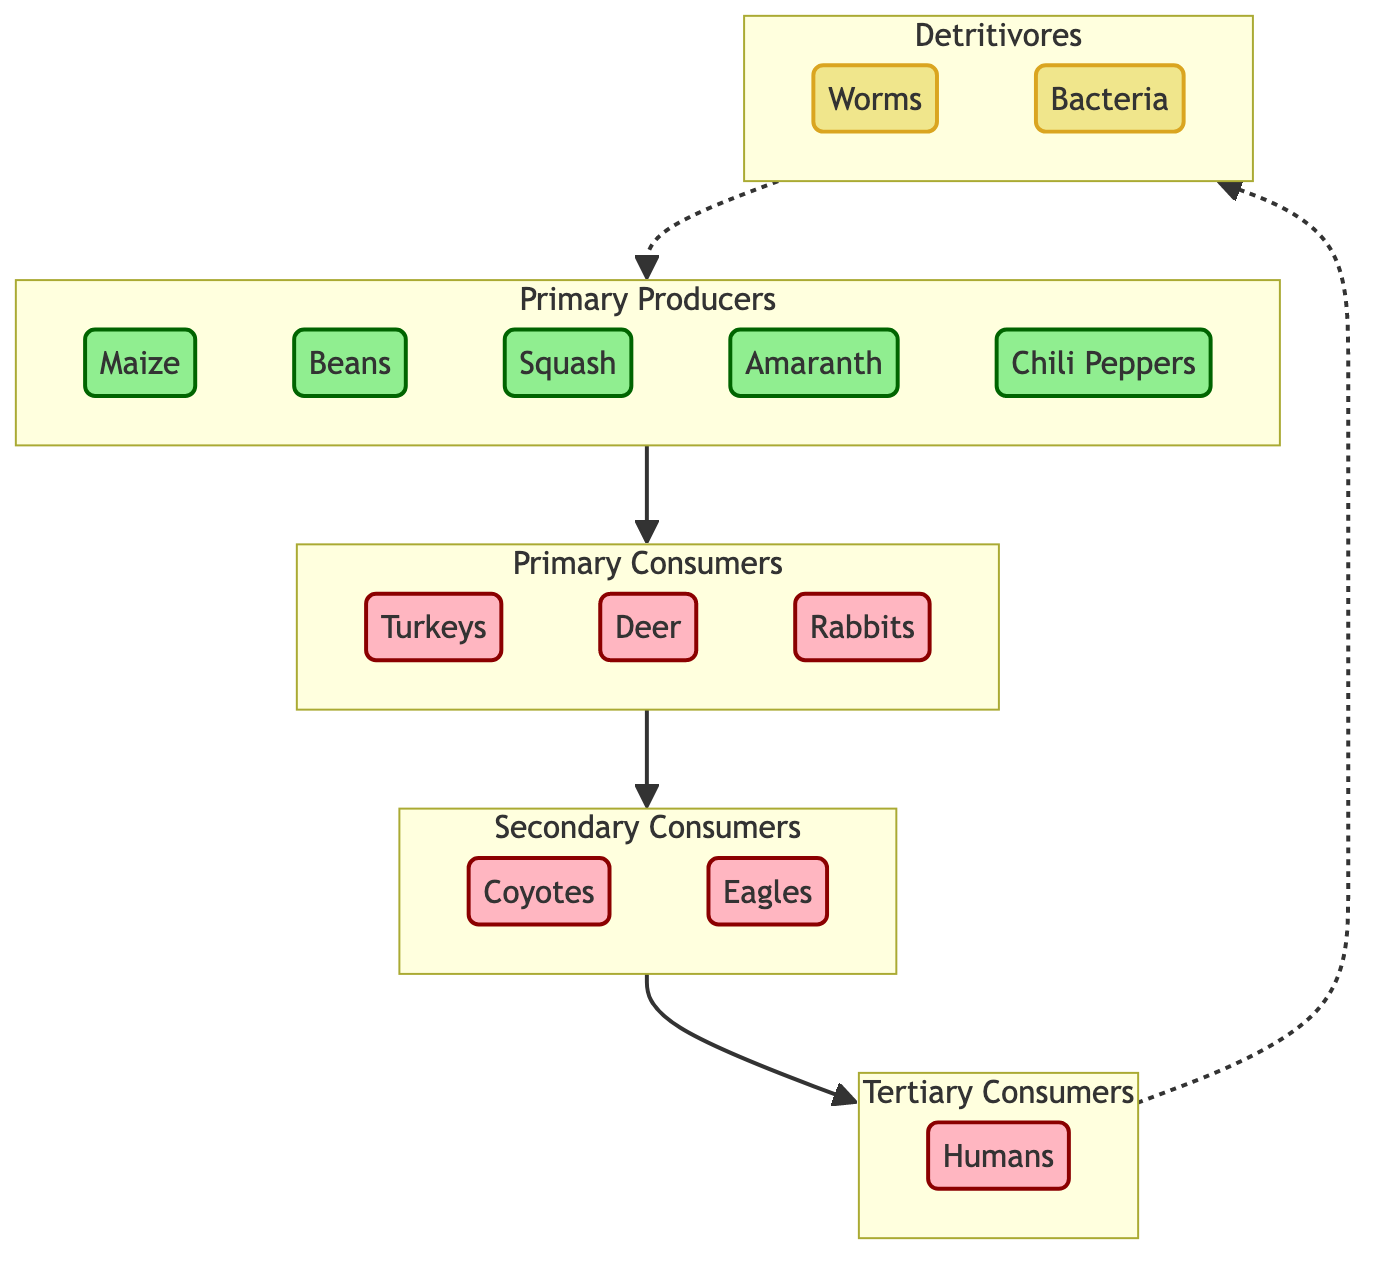What are the primary producers in the Aztec agricultural system? The diagram lists maize, beans, squash, amaranth, and chili peppers as primary producers. These are at the top of the diagram under the "Primary Producers" subgraph.
Answer: Maize, beans, squash, amaranth, chili peppers How many primary consumers are present in the diagram? The diagram includes three primary consumers: turkeys, deer, and rabbits. They are listed in the "Primary Consumers" subgraph.
Answer: 3 Which group is at the top of the food chain? The diagram shows humans as the group at the top of the food chain, located in the "Tertiary Consumers" subgraph.
Answer: Humans What do detritivores return to the system? Detritivores, such as worms and bacteria, return nutrients to the soil, completing the cycle back to primary producers. This relationship is indicated by the dashed line connecting detritivores to primary producers.
Answer: Nutrients Which consumer does not directly feed on primary producers? Secondary consumers like coyotes and eagles do not feed directly on primary producers; they feed on primary consumers instead. This is shown as the connection from primary consumers to secondary consumers.
Answer: Secondary consumers How many levels are there in this trophic structure? The diagram showcases four levels: primary producers, primary consumers, secondary consumers, and tertiary consumers, plus detritivores. This establishes the hierarchy of the food chain.
Answer: 4 Do primary consumers include any mammals? Yes, the primary consumers listed in the diagram include deer and rabbits, both of which are mammals as seen in the "Primary Consumers" subgraph.
Answer: Yes Which organism is a tertiary consumer in the Aztec food chain? The diagram identifies humans as the only tertiary consumer in the food chain, located in the "Tertiary Consumers" subgraph.
Answer: Humans What role do bacteria play in the Aztec agricultural ecosystem? Bacteria function as detritivores, helping to decompose organic matter and return nutrients to the soil, as shown in the "Detritivores" subgraph connected to primary producers.
Answer: Decomposers 